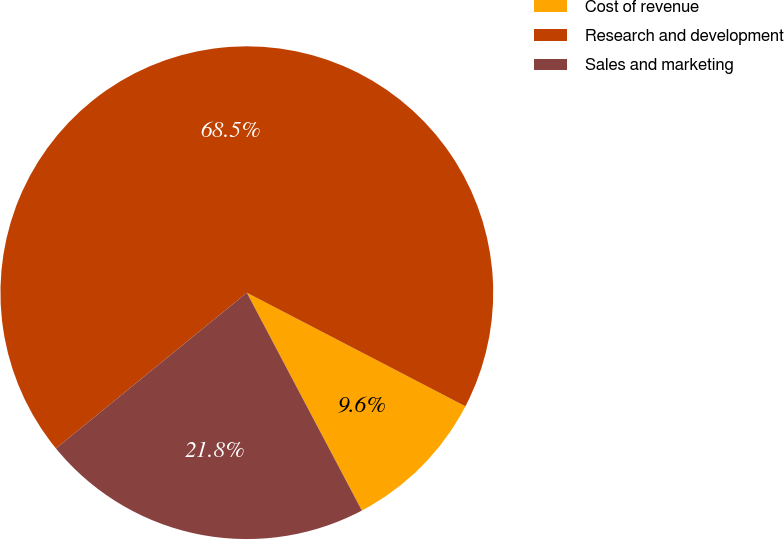Convert chart. <chart><loc_0><loc_0><loc_500><loc_500><pie_chart><fcel>Cost of revenue<fcel>Research and development<fcel>Sales and marketing<nl><fcel>9.64%<fcel>68.52%<fcel>21.84%<nl></chart> 